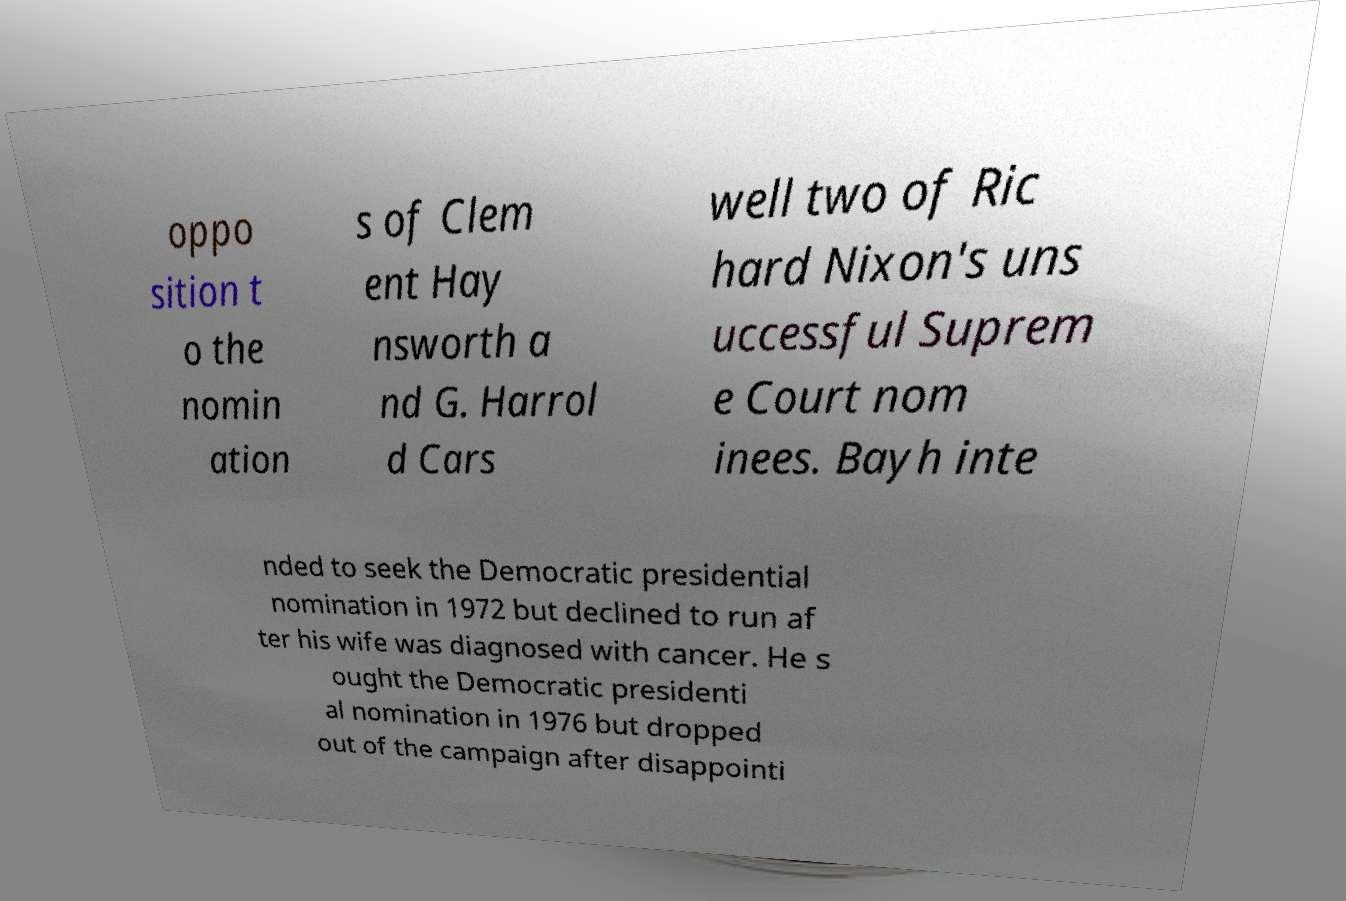Can you read and provide the text displayed in the image?This photo seems to have some interesting text. Can you extract and type it out for me? oppo sition t o the nomin ation s of Clem ent Hay nsworth a nd G. Harrol d Cars well two of Ric hard Nixon's uns uccessful Suprem e Court nom inees. Bayh inte nded to seek the Democratic presidential nomination in 1972 but declined to run af ter his wife was diagnosed with cancer. He s ought the Democratic presidenti al nomination in 1976 but dropped out of the campaign after disappointi 